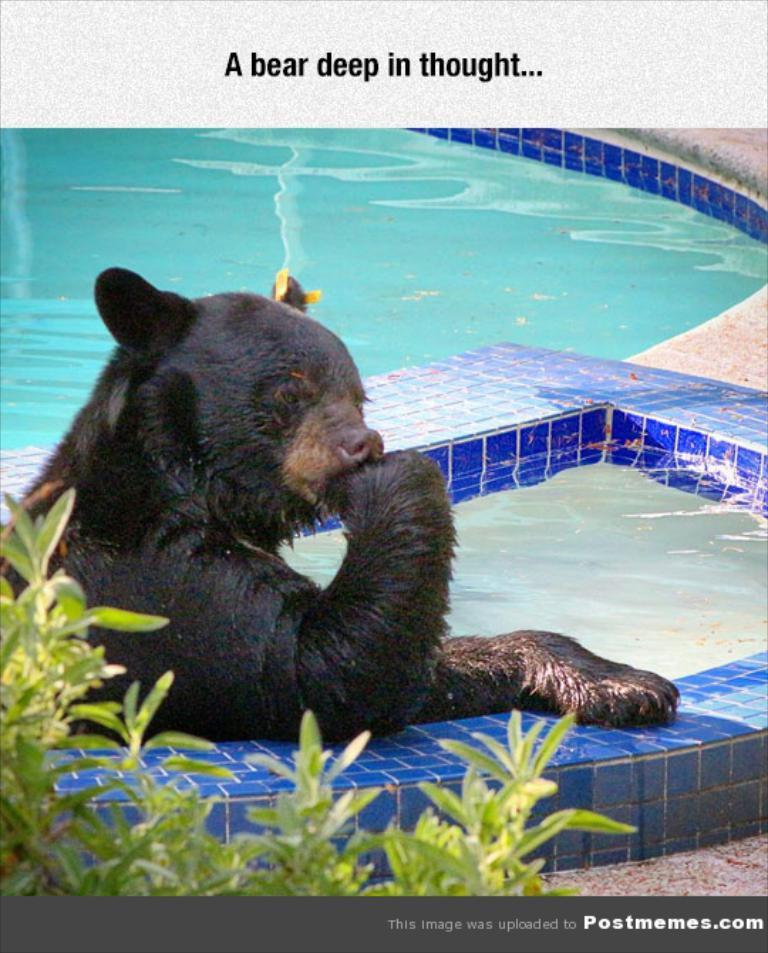What animal is in the swimming pool in the image? There is a bear in the swimming pool in the image. What can be seen near the swimming pool? There is a plant at the side of the pool. Is there any text present in the image? Yes, there is text written on the image. What type of tomatoes are growing on the plant near the pool? There are no tomatoes present in the image; the plant is not specified as a tomato plant. 